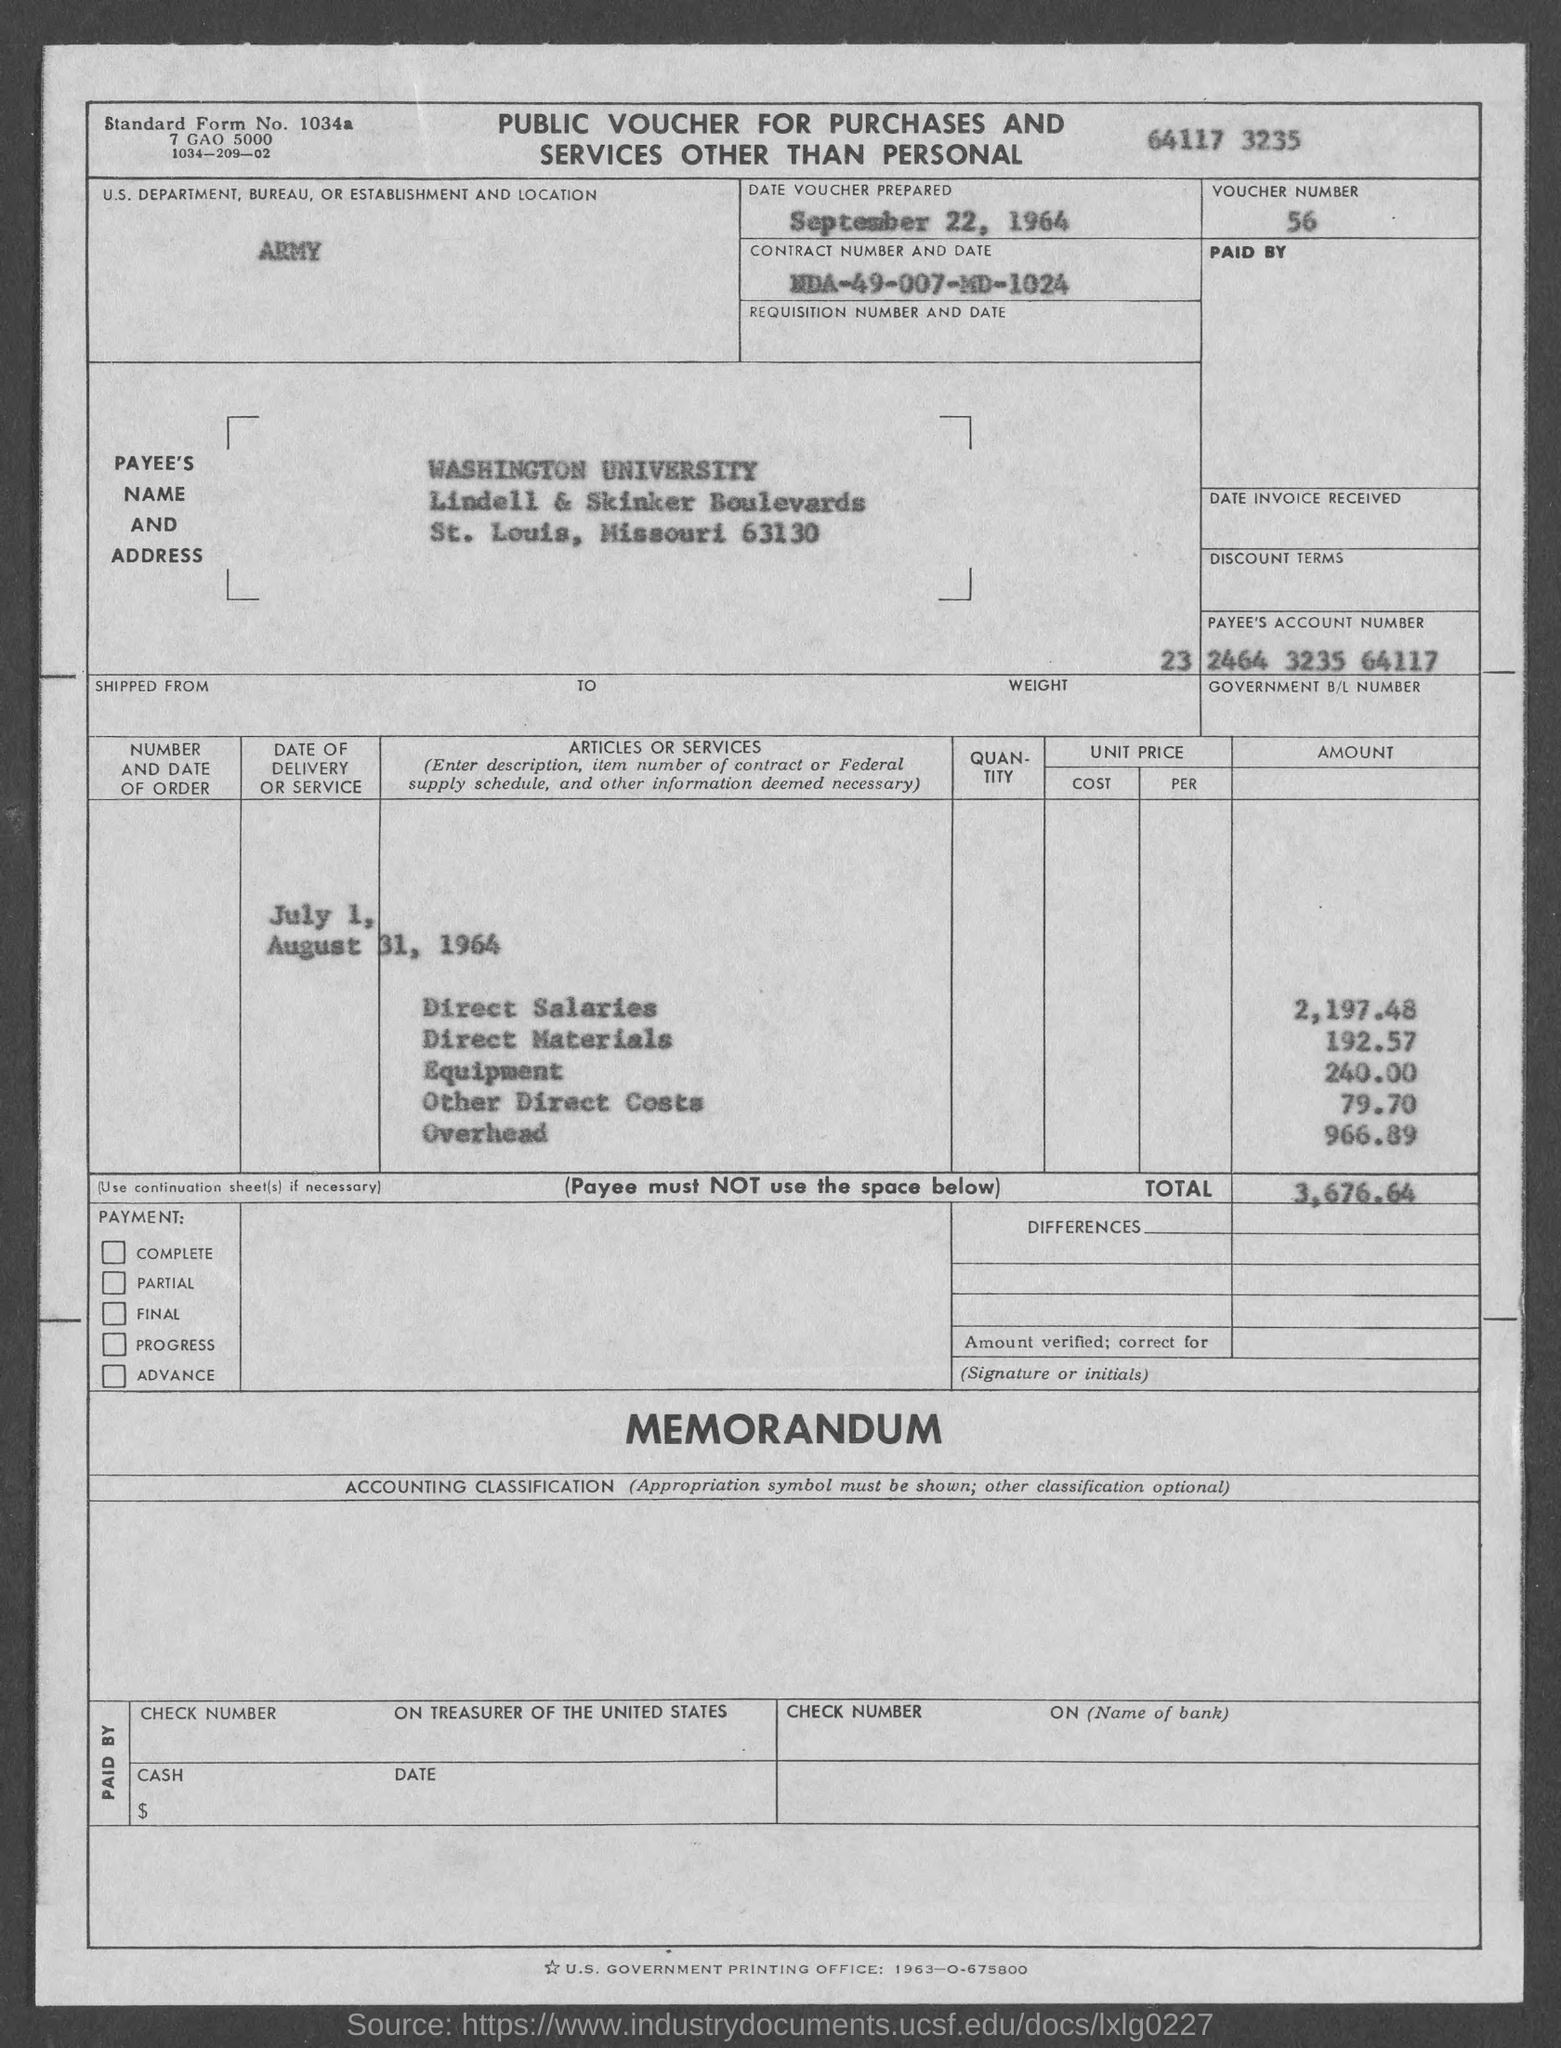What is the Direct salaries amount?
 2,197.48 